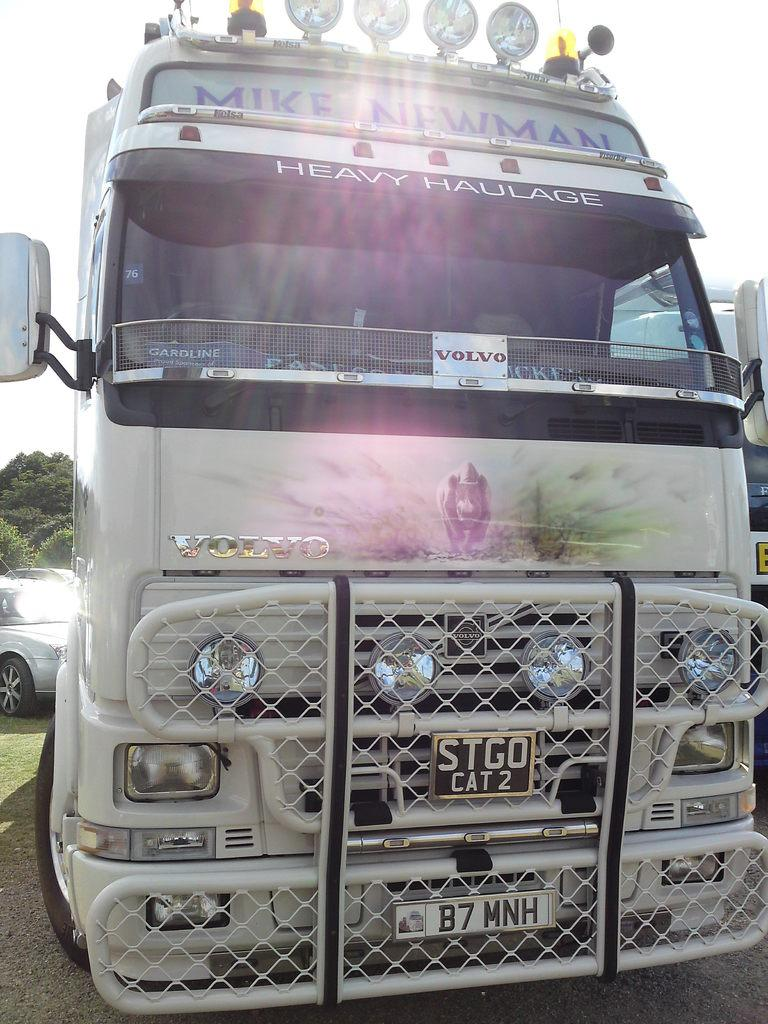<image>
Create a compact narrative representing the image presented. A semi truck with a large front grille says Volvo. 